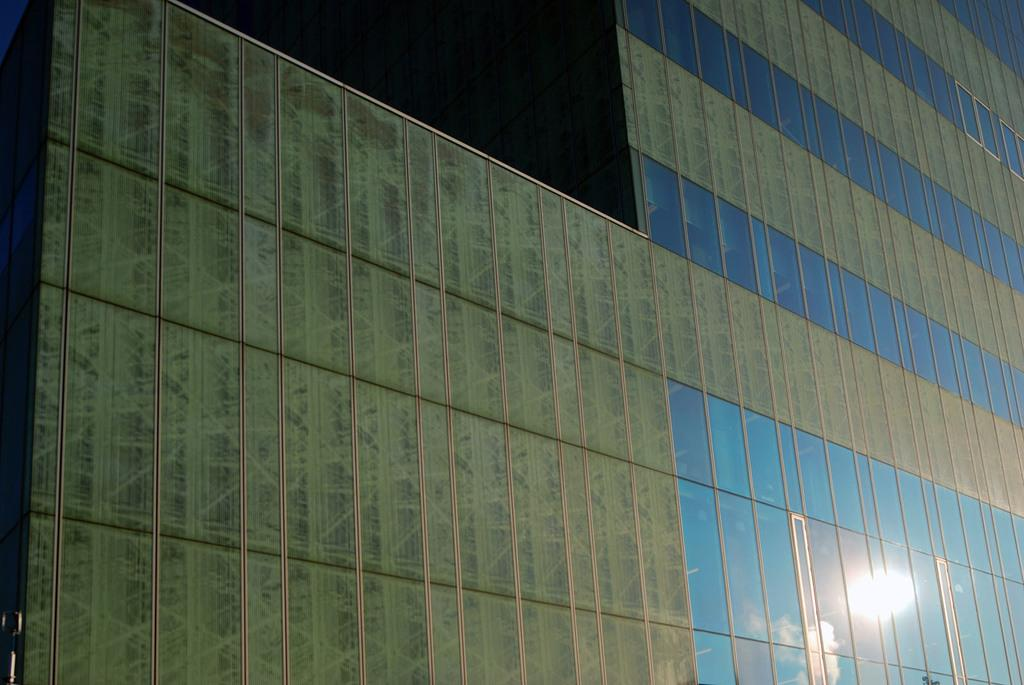What material are the walls made of in the image? The walls in the image are made of glass. What type of structure is the glass walls part of? The glass walls are part of a building. Can you see a bird sitting on a swing made of metal in the image? No, there is no bird, swing, or metal object present in the image. 